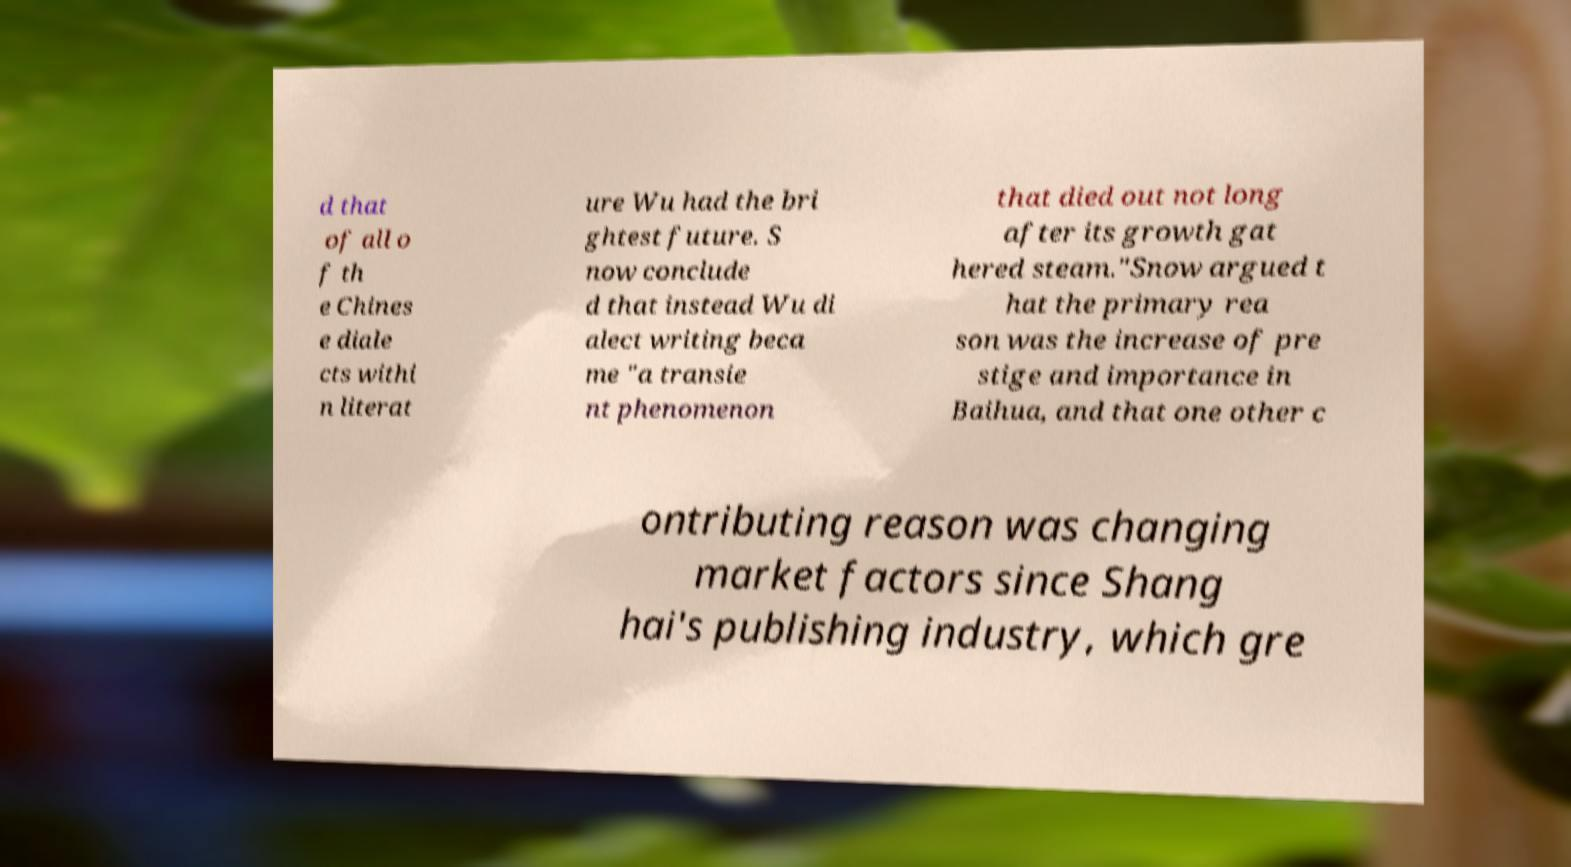Could you assist in decoding the text presented in this image and type it out clearly? d that of all o f th e Chines e diale cts withi n literat ure Wu had the bri ghtest future. S now conclude d that instead Wu di alect writing beca me "a transie nt phenomenon that died out not long after its growth gat hered steam."Snow argued t hat the primary rea son was the increase of pre stige and importance in Baihua, and that one other c ontributing reason was changing market factors since Shang hai's publishing industry, which gre 